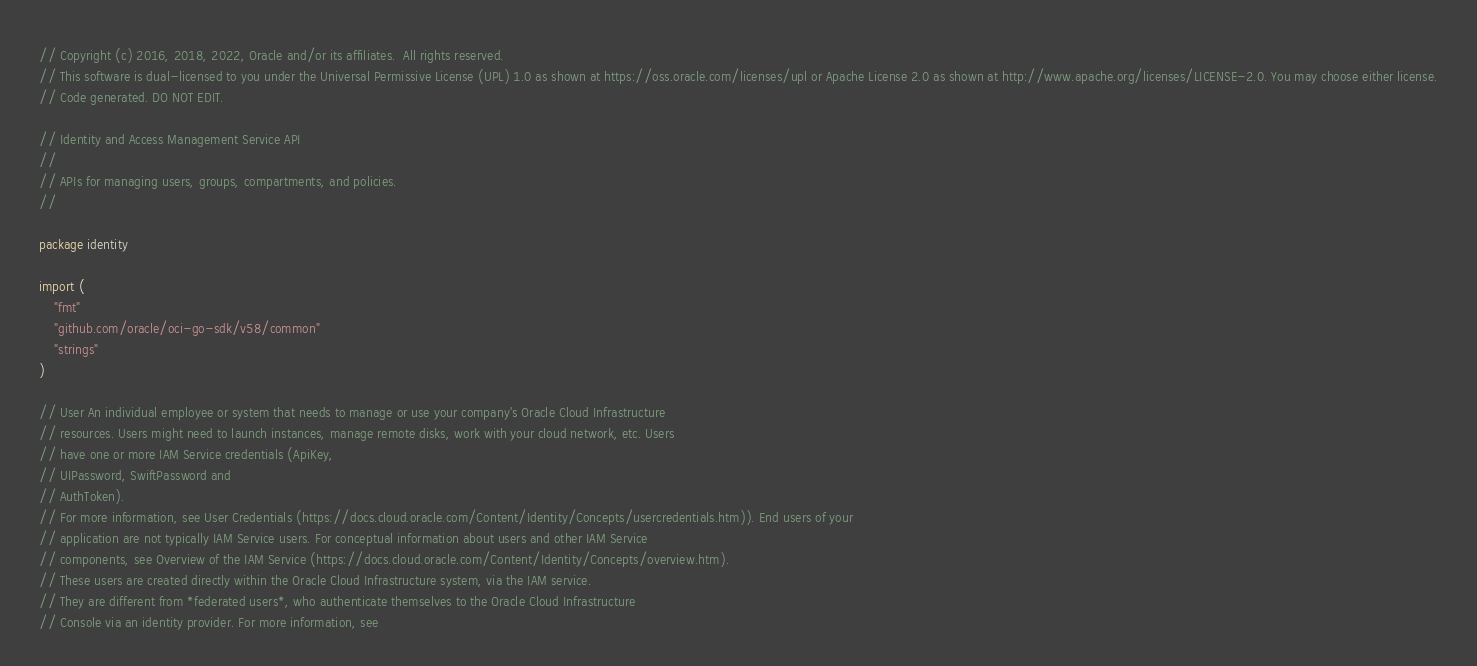Convert code to text. <code><loc_0><loc_0><loc_500><loc_500><_Go_>// Copyright (c) 2016, 2018, 2022, Oracle and/or its affiliates.  All rights reserved.
// This software is dual-licensed to you under the Universal Permissive License (UPL) 1.0 as shown at https://oss.oracle.com/licenses/upl or Apache License 2.0 as shown at http://www.apache.org/licenses/LICENSE-2.0. You may choose either license.
// Code generated. DO NOT EDIT.

// Identity and Access Management Service API
//
// APIs for managing users, groups, compartments, and policies.
//

package identity

import (
	"fmt"
	"github.com/oracle/oci-go-sdk/v58/common"
	"strings"
)

// User An individual employee or system that needs to manage or use your company's Oracle Cloud Infrastructure
// resources. Users might need to launch instances, manage remote disks, work with your cloud network, etc. Users
// have one or more IAM Service credentials (ApiKey,
// UIPassword, SwiftPassword and
// AuthToken).
// For more information, see User Credentials (https://docs.cloud.oracle.com/Content/Identity/Concepts/usercredentials.htm)). End users of your
// application are not typically IAM Service users. For conceptual information about users and other IAM Service
// components, see Overview of the IAM Service (https://docs.cloud.oracle.com/Content/Identity/Concepts/overview.htm).
// These users are created directly within the Oracle Cloud Infrastructure system, via the IAM service.
// They are different from *federated users*, who authenticate themselves to the Oracle Cloud Infrastructure
// Console via an identity provider. For more information, see</code> 